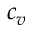Convert formula to latex. <formula><loc_0><loc_0><loc_500><loc_500>c _ { v }</formula> 